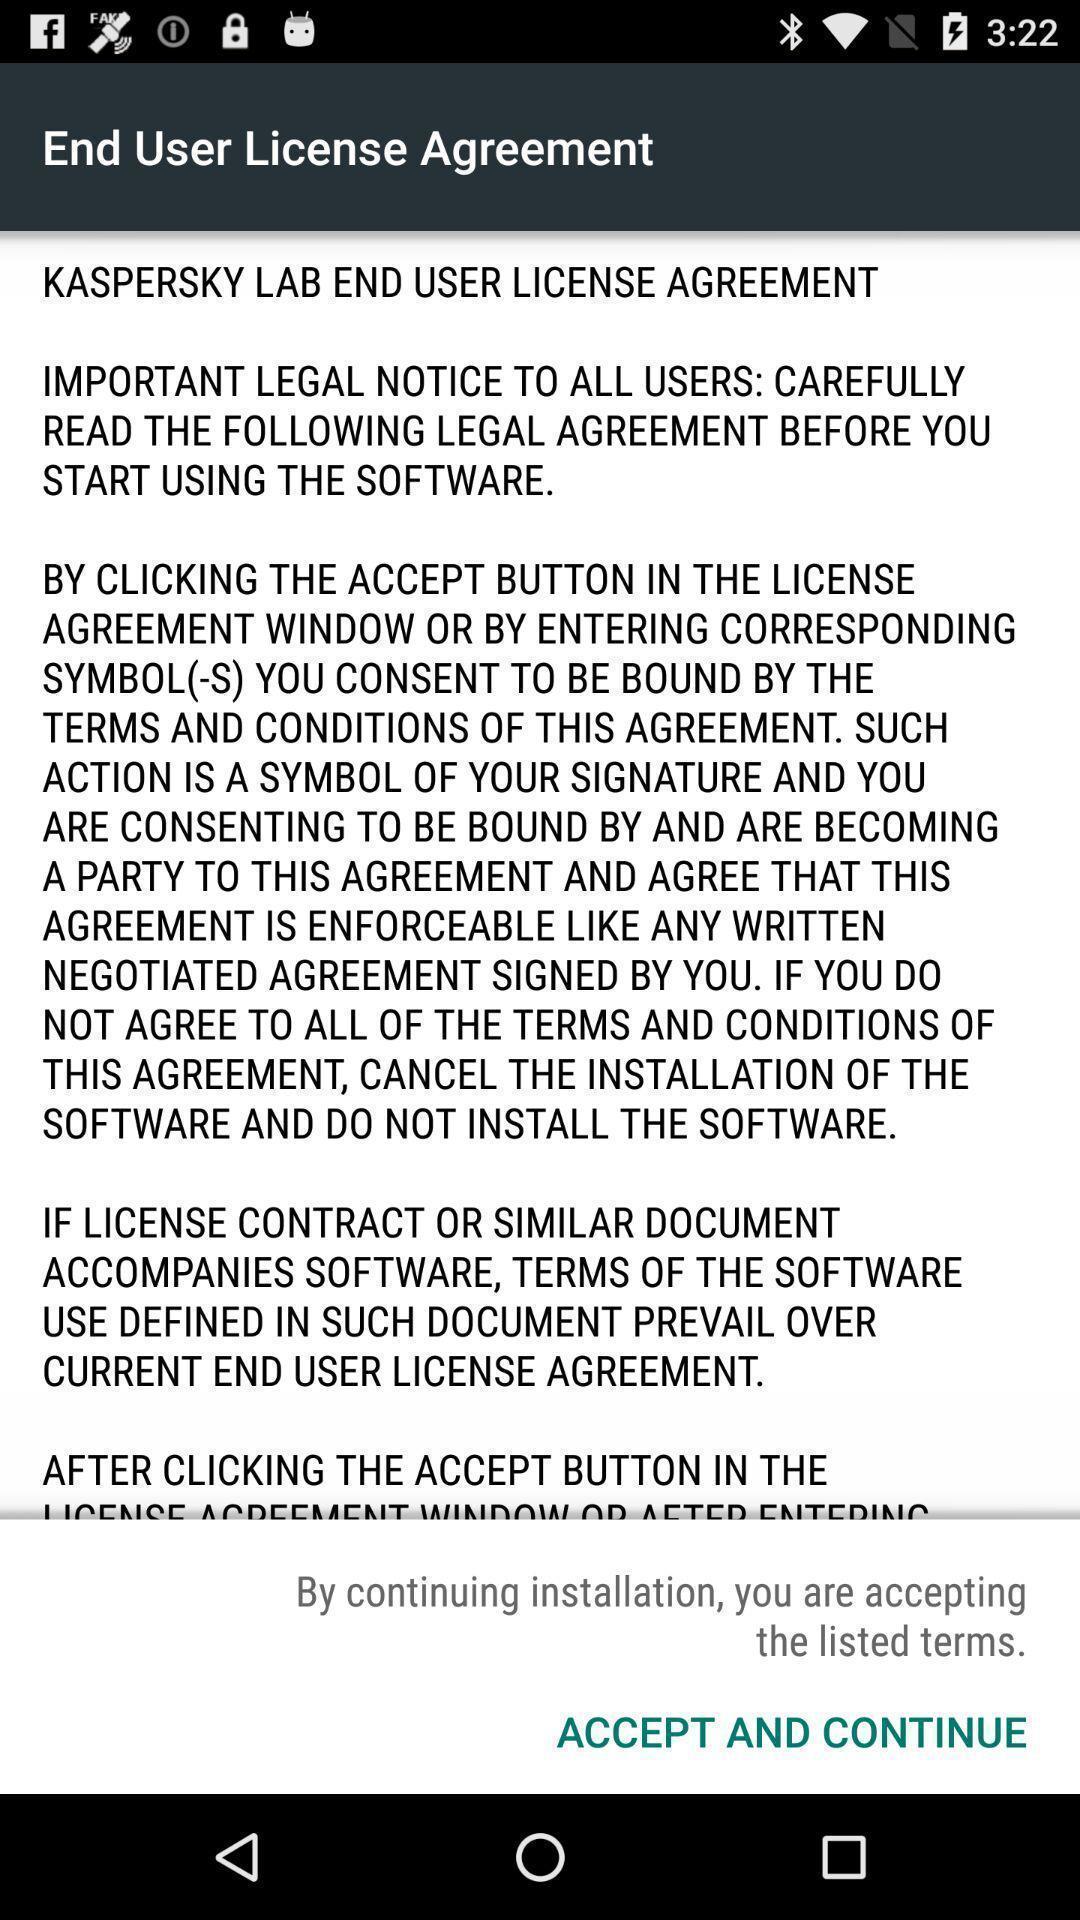Describe the visual elements of this screenshot. Screen displaying the end user license agreement. 